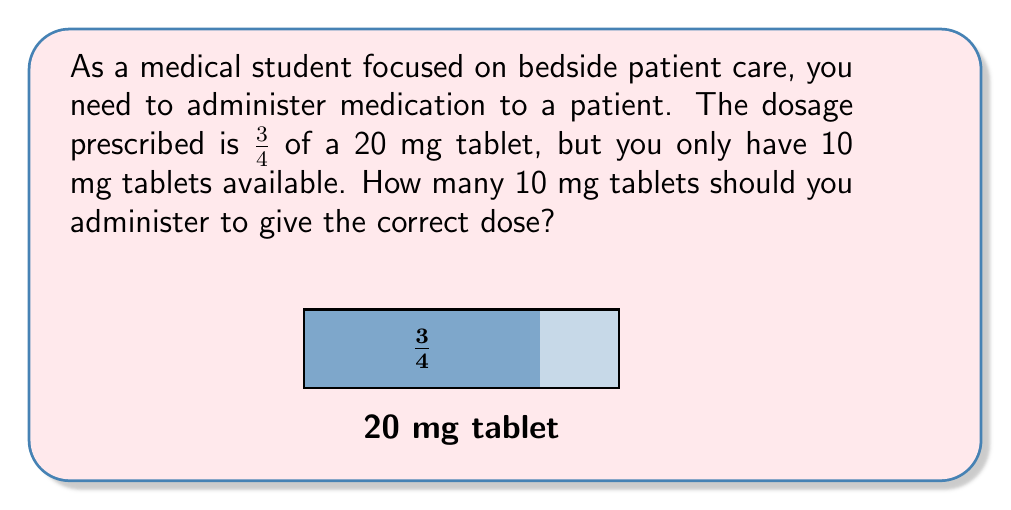Help me with this question. Let's approach this step-by-step:

1) First, calculate the prescribed dose:
   $$\frac{3}{4} \text{ of } 20 \text{ mg} = \frac{3}{4} \times 20 \text{ mg} = 15 \text{ mg}$$

2) Now, we need to determine how many 10 mg tablets are equivalent to 15 mg:
   $$\frac{15 \text{ mg}}{10 \text{ mg/tablet}} = 1.5 \text{ tablets}$$

3) To express this as a fraction:
   $$1.5 \text{ tablets} = \frac{3}{2} \text{ tablets}$$

Therefore, you need to administer $\frac{3}{2}$ of a 10 mg tablet to give the correct dose of 15 mg.
Answer: $\frac{3}{2}$ tablets 